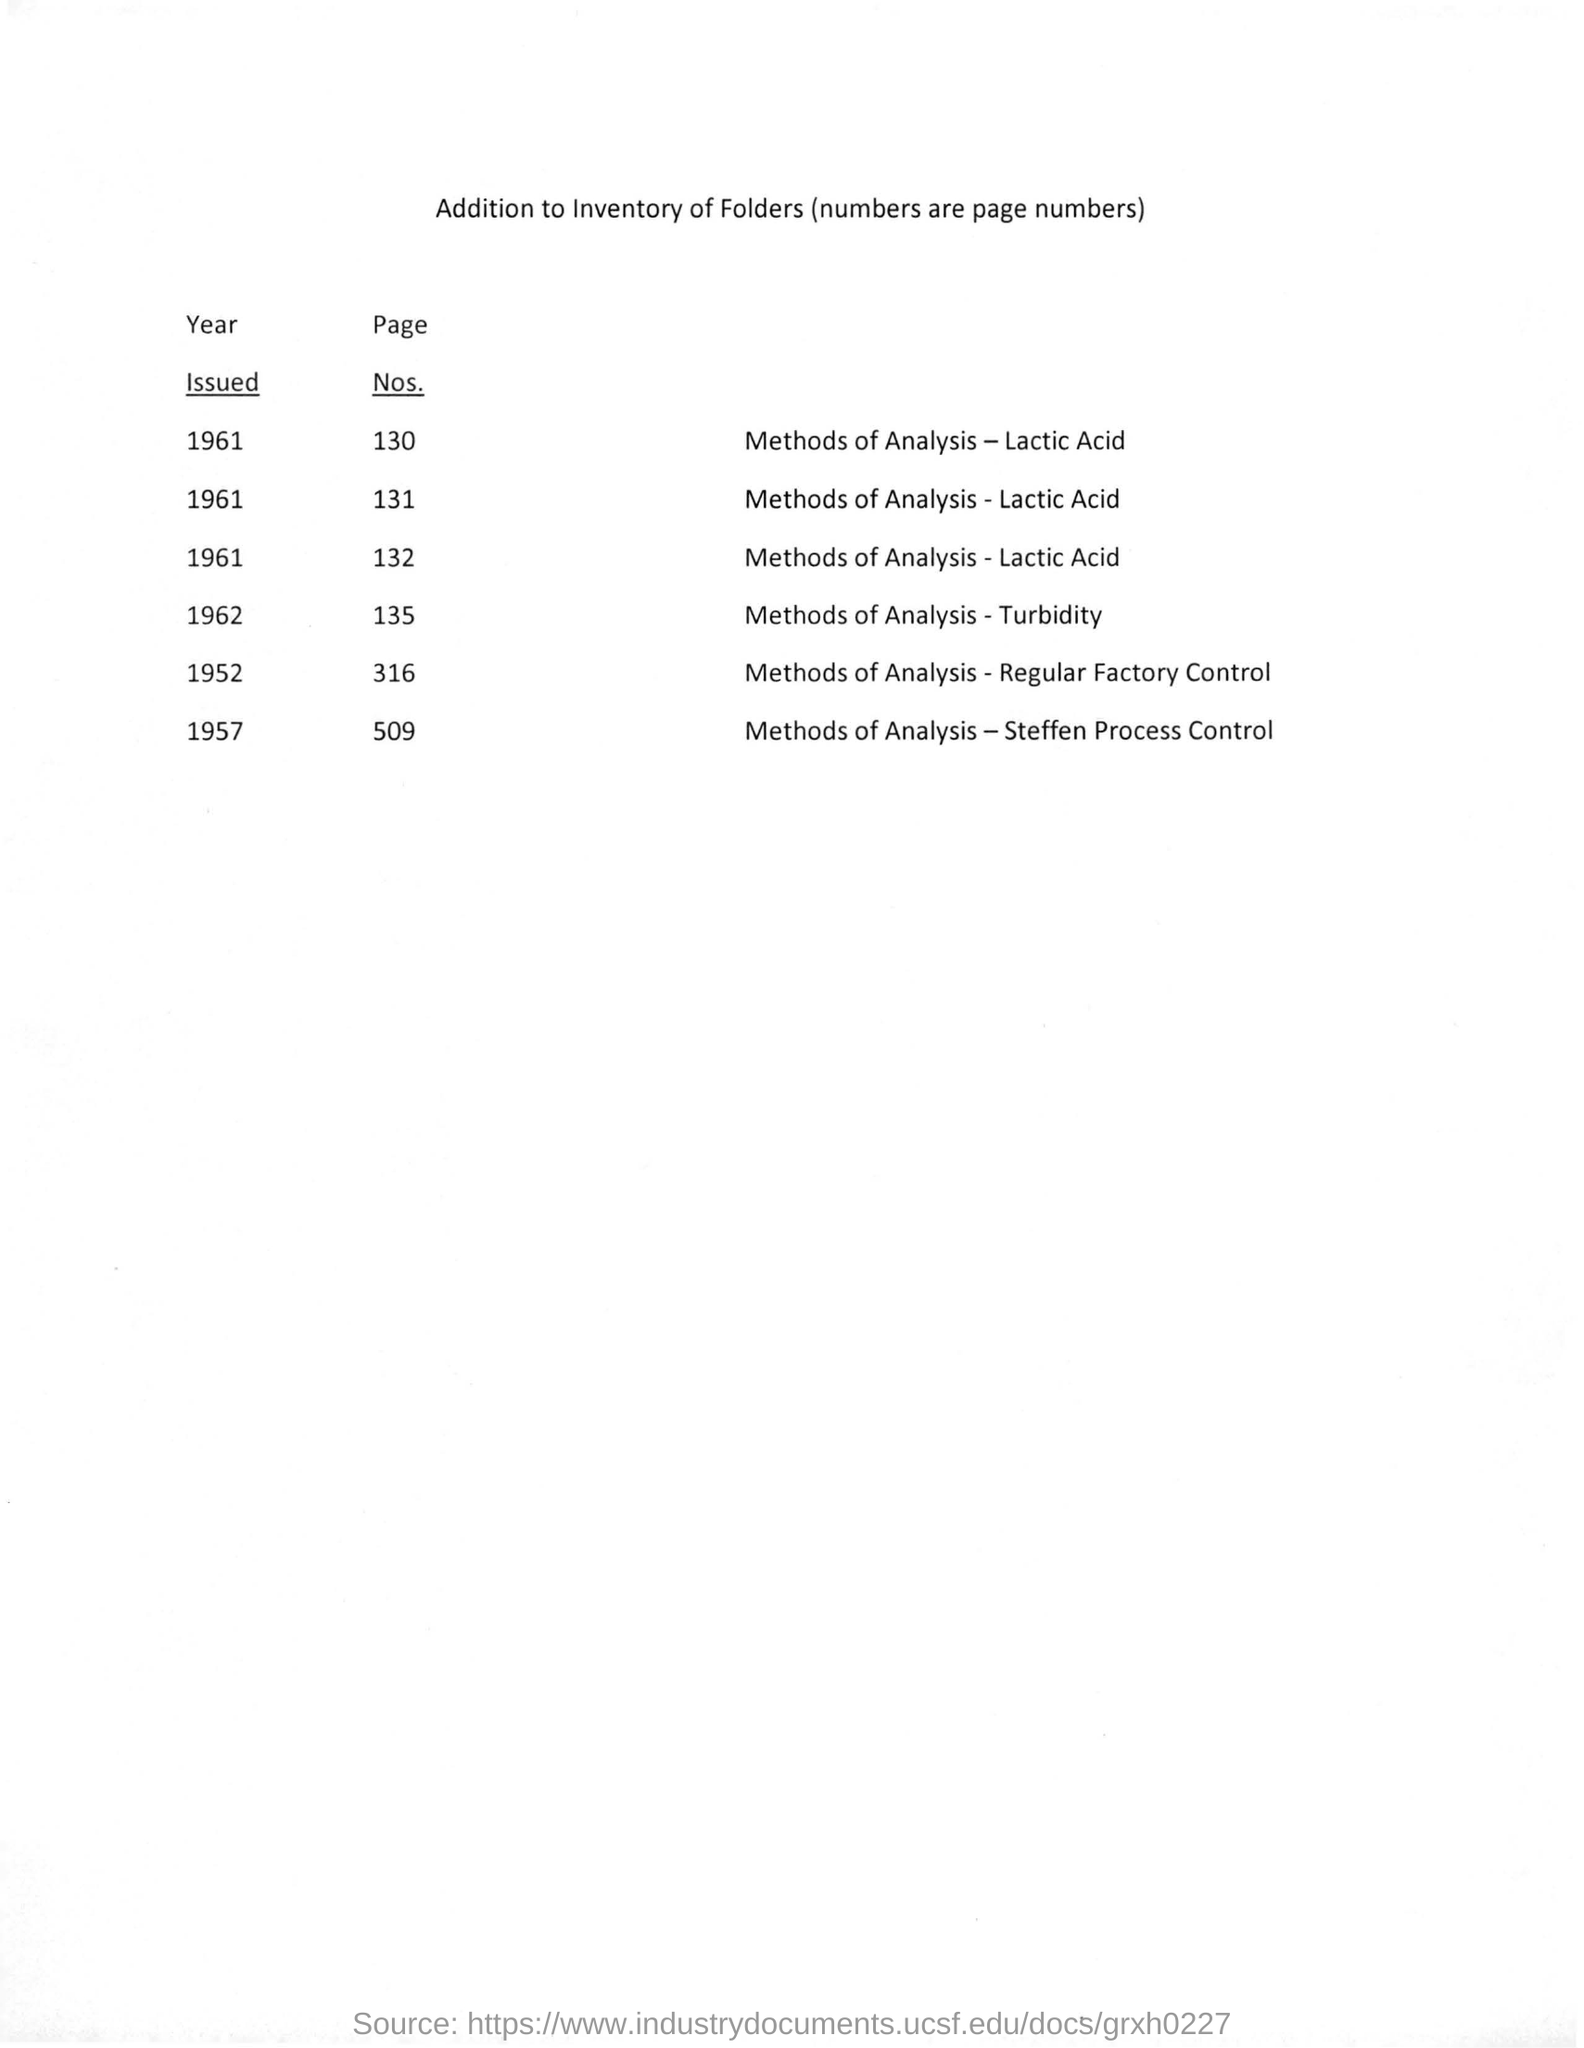Point out several critical features in this image. There are 316 pages mentioned for the method of analysis used in regular factory control. The method of analysis for turbidity was first introduced in 1962. There are 509 pages in the method of analysis for Steffen process control. 